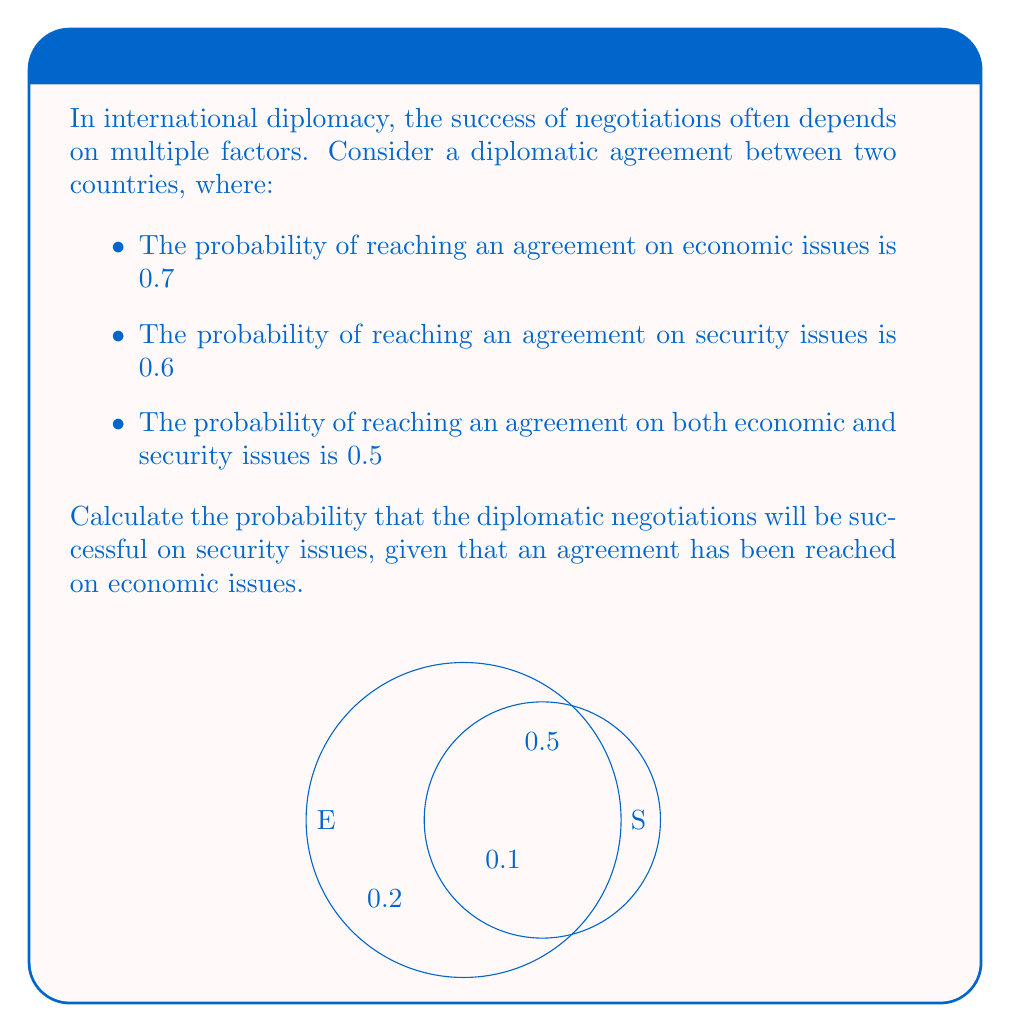What is the answer to this math problem? To solve this problem, we'll use the concept of conditional probability. Let's define our events:

E: Agreement reached on economic issues
S: Agreement reached on security issues

We're given:
$P(E) = 0.7$
$P(S) = 0.6$
$P(E \cap S) = 0.5$

We need to find $P(S|E)$, which is the probability of S given E.

The formula for conditional probability is:

$$P(S|E) = \frac{P(E \cap S)}{P(E)}$$

We have all the information needed to plug into this formula:

$$P(S|E) = \frac{0.5}{0.7}$$

Calculating:

$$P(S|E) = \frac{5}{7} \approx 0.7143$$

This result can be interpreted as: given that an agreement has been reached on economic issues, there is approximately a 71.43% chance that an agreement will also be reached on security issues.

To verify this result, we can use the Venn diagram provided in the question:
- The probability of E is 0.7 (0.5 + 0.2)
- The probability of S is 0.6 (0.5 + 0.1)
- The probability of both E and S is 0.5

This visual representation confirms our calculation.
Answer: $\frac{5}{7} \approx 0.7143$ 